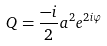Convert formula to latex. <formula><loc_0><loc_0><loc_500><loc_500>Q = \frac { - i } { 2 } a ^ { 2 } e ^ { 2 i \varphi }</formula> 